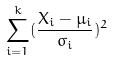<formula> <loc_0><loc_0><loc_500><loc_500>\sum _ { i = 1 } ^ { k } ( \frac { X _ { i } - \mu _ { i } } { \sigma _ { i } } ) ^ { 2 }</formula> 